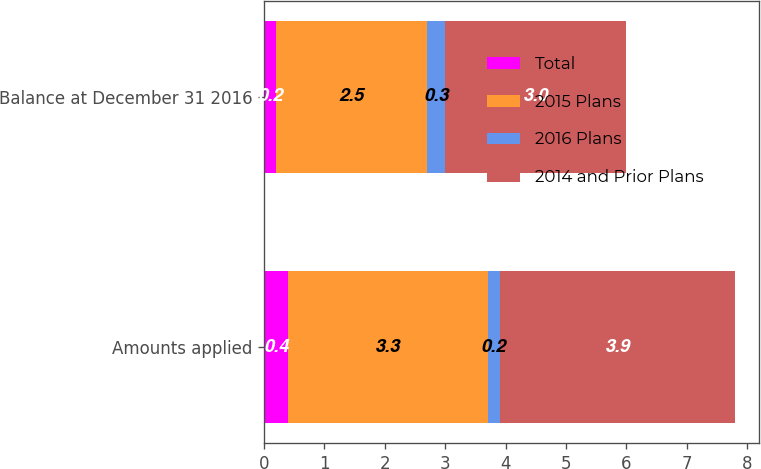Convert chart to OTSL. <chart><loc_0><loc_0><loc_500><loc_500><stacked_bar_chart><ecel><fcel>Amounts applied<fcel>Balance at December 31 2016<nl><fcel>Total<fcel>0.4<fcel>0.2<nl><fcel>2015 Plans<fcel>3.3<fcel>2.5<nl><fcel>2016 Plans<fcel>0.2<fcel>0.3<nl><fcel>2014 and Prior Plans<fcel>3.9<fcel>3<nl></chart> 